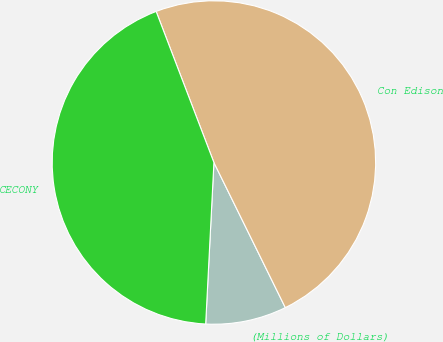Convert chart. <chart><loc_0><loc_0><loc_500><loc_500><pie_chart><fcel>(Millions of Dollars)<fcel>Con Edison<fcel>CECONY<nl><fcel>8.09%<fcel>48.54%<fcel>43.38%<nl></chart> 